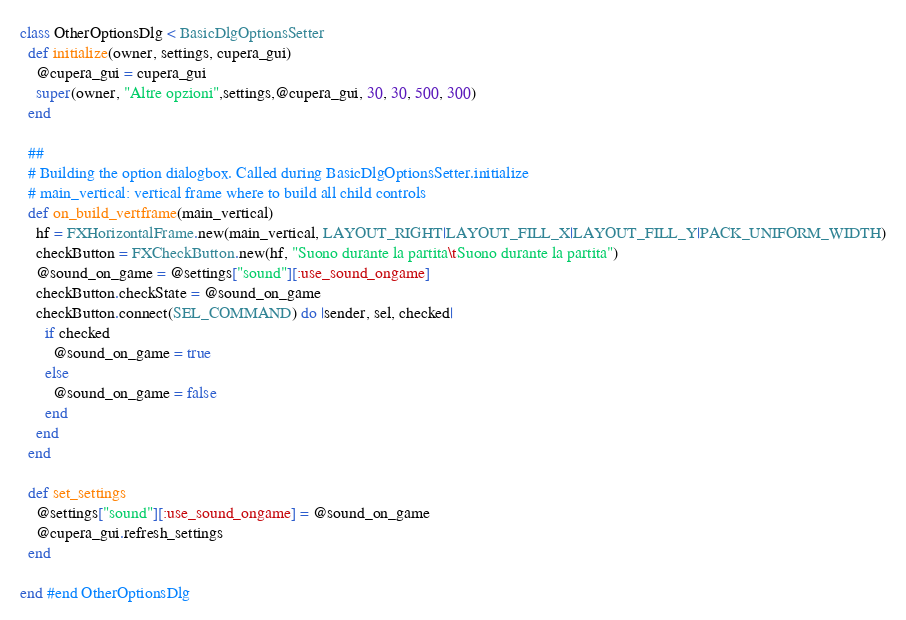Convert code to text. <code><loc_0><loc_0><loc_500><loc_500><_Ruby_>
class OtherOptionsDlg < BasicDlgOptionsSetter
  def initialize(owner, settings, cupera_gui)
    @cupera_gui = cupera_gui
    super(owner, "Altre opzioni",settings,@cupera_gui, 30, 30, 500, 300)  
  end
  
  ##
  # Building the option dialogbox. Called during BasicDlgOptionsSetter.initialize
  # main_vertical: vertical frame where to build all child controls
  def on_build_vertframe(main_vertical)
    hf = FXHorizontalFrame.new(main_vertical, LAYOUT_RIGHT|LAYOUT_FILL_X|LAYOUT_FILL_Y|PACK_UNIFORM_WIDTH)
    checkButton = FXCheckButton.new(hf, "Suono durante la partita\tSuono durante la partita")
    @sound_on_game = @settings["sound"][:use_sound_ongame]
    checkButton.checkState = @sound_on_game
    checkButton.connect(SEL_COMMAND) do |sender, sel, checked|
      if checked
        @sound_on_game = true
      else
        @sound_on_game = false
      end
    end
  end
  
  def set_settings
    @settings["sound"][:use_sound_ongame] = @sound_on_game 
    @cupera_gui.refresh_settings
  end
  
end #end OtherOptionsDlg
</code> 